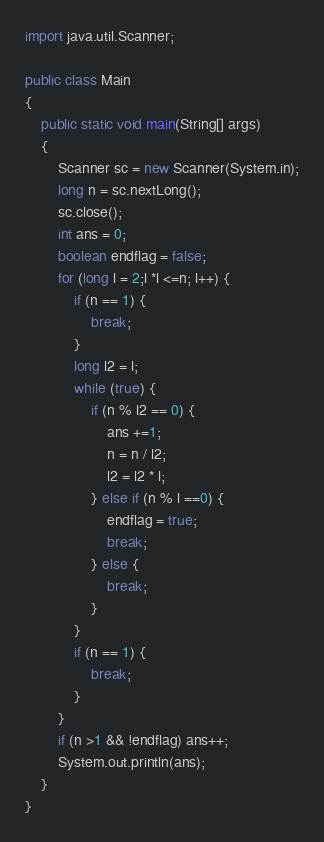Convert code to text. <code><loc_0><loc_0><loc_500><loc_500><_Java_>import java.util.Scanner;

public class Main
{
	public static void main(String[] args)
	{
		Scanner sc = new Scanner(System.in);
		long n = sc.nextLong();
		sc.close();
		int ans = 0;
		boolean endflag = false;
		for (long l = 2;l *l <=n; l++) {
			if (n == 1) {
				break;
			}
			long l2 = l;
			while (true) {
				if (n % l2 == 0) {
					ans +=1;
					n = n / l2;
					l2 = l2 * l;
				} else if (n % l ==0) {
					endflag = true;
					break;
				} else {
					break;
				}
			}
			if (n == 1) {
				break;
			}
		}
		if (n >1 && !endflag) ans++;
		System.out.println(ans);
	}
}
</code> 